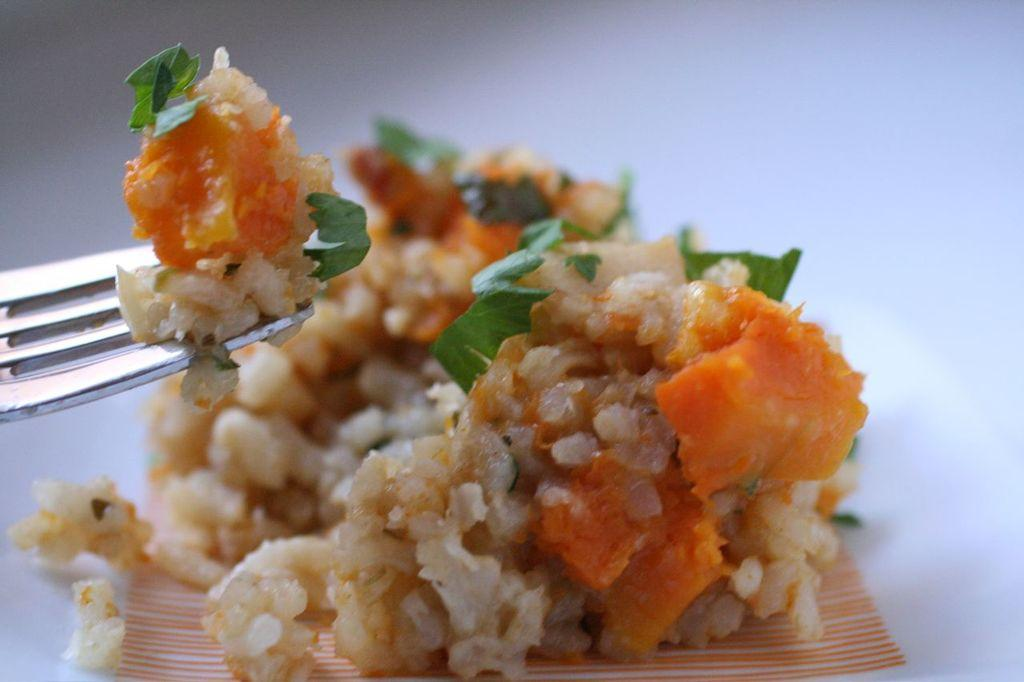What is the main feature of the image? The main feature of the image is a white surface with a design. What else can be seen on the white surface? There is food and a fork present on the white surface. What type of chalk is being used to draw the design on the white surface? There is no chalk present in the image; the design is already on the white surface. How does the curve of the design affect the overall appearance of the image? The image does not contain a curve in the design, so this question cannot be answered based on the provided facts. 